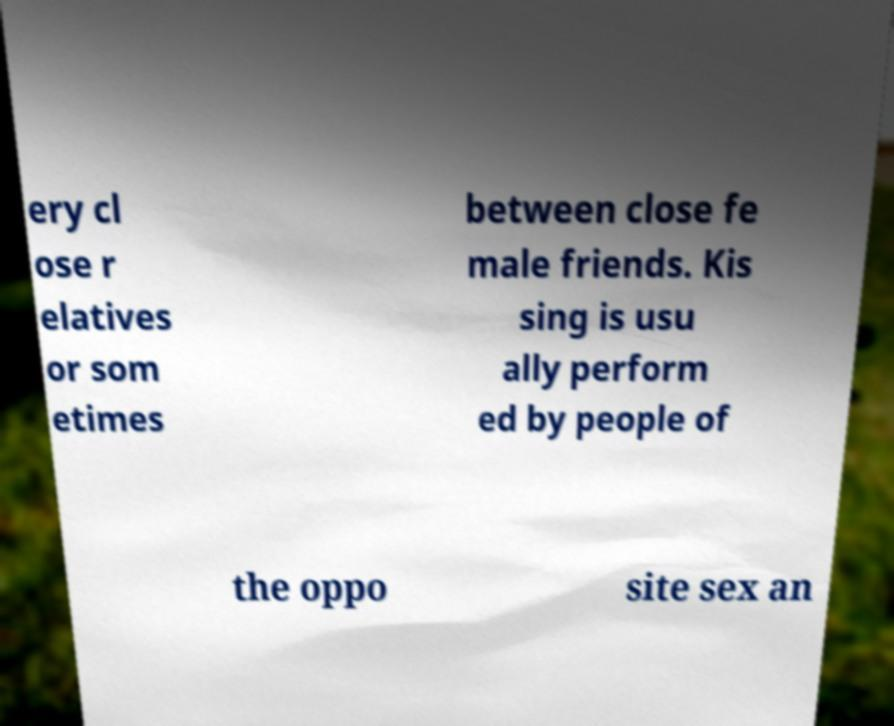Can you accurately transcribe the text from the provided image for me? ery cl ose r elatives or som etimes between close fe male friends. Kis sing is usu ally perform ed by people of the oppo site sex an 